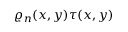Convert formula to latex. <formula><loc_0><loc_0><loc_500><loc_500>\varrho _ { n } ( x , y ) \tau ( x , y )</formula> 